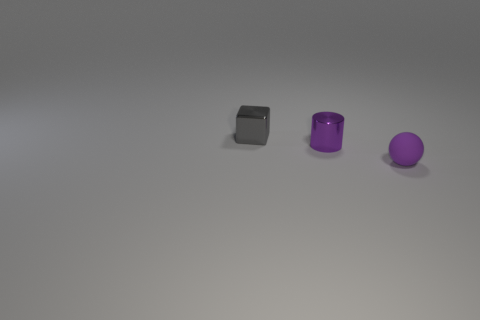How many green things are small metal cubes or tiny things?
Your answer should be very brief. 0. Are there more metallic cylinders than tiny yellow balls?
Keep it short and to the point. Yes. What color is the cylinder that is the same size as the metal cube?
Ensure brevity in your answer.  Purple. How many blocks are either green shiny things or small purple objects?
Offer a terse response. 0. There is a small matte thing; does it have the same shape as the tiny purple object that is to the left of the small matte sphere?
Your answer should be compact. No. How many purple balls are the same size as the purple cylinder?
Provide a succinct answer. 1. Does the purple object that is left of the small matte ball have the same shape as the purple thing in front of the tiny purple metal object?
Your response must be concise. No. What shape is the other object that is the same color as the rubber thing?
Your answer should be compact. Cylinder. There is a object behind the metal object that is right of the gray block; what color is it?
Offer a terse response. Gray. Is there any other thing that has the same material as the gray thing?
Your response must be concise. Yes. 